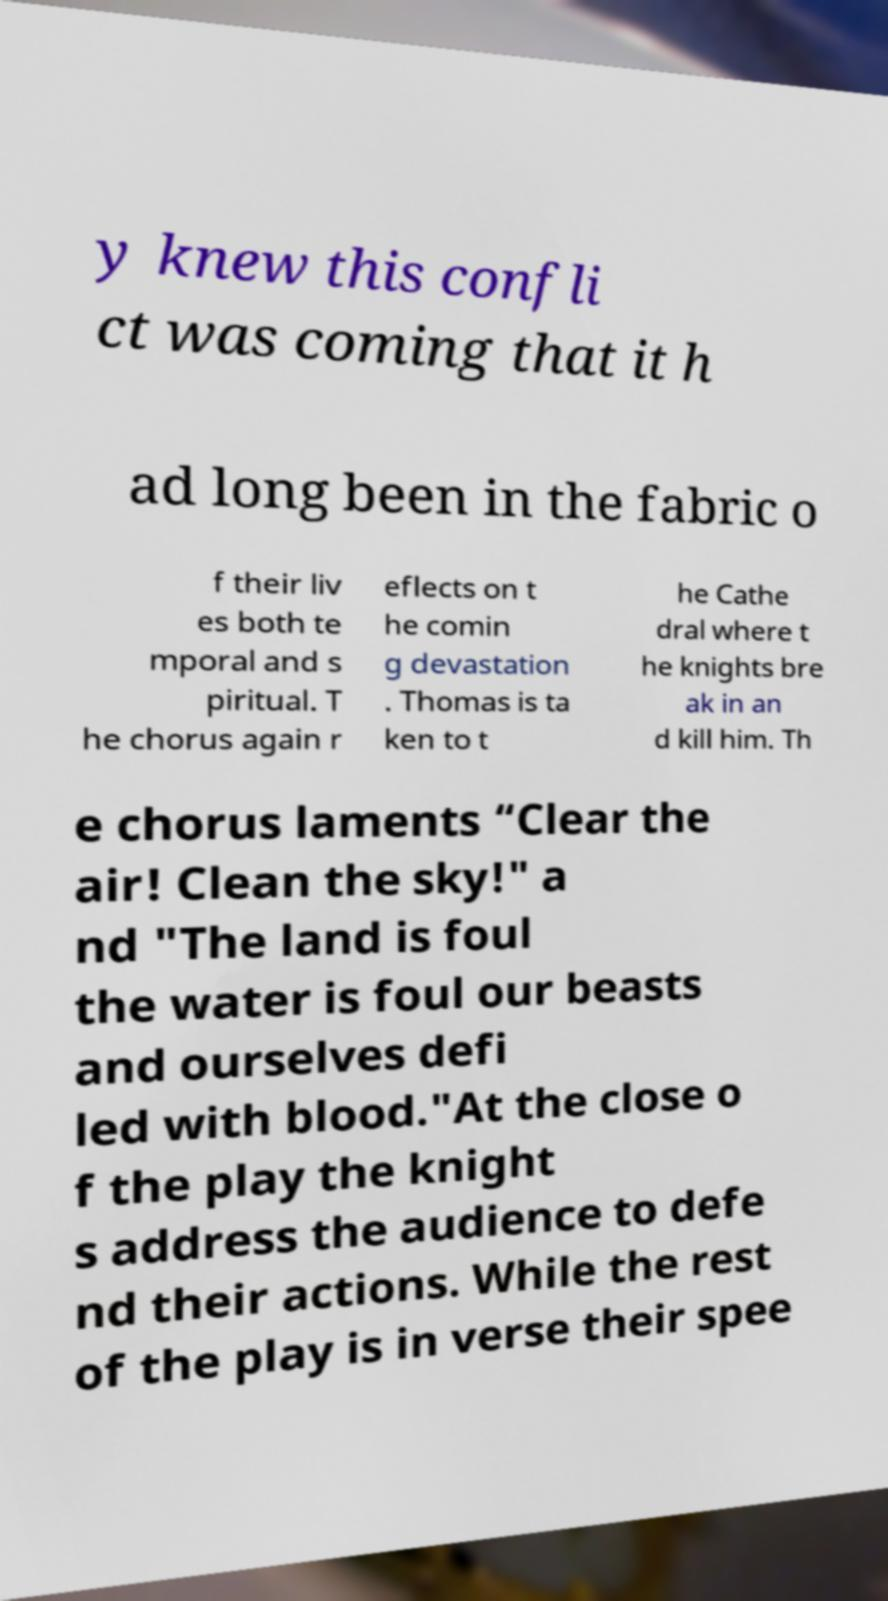For documentation purposes, I need the text within this image transcribed. Could you provide that? y knew this confli ct was coming that it h ad long been in the fabric o f their liv es both te mporal and s piritual. T he chorus again r eflects on t he comin g devastation . Thomas is ta ken to t he Cathe dral where t he knights bre ak in an d kill him. Th e chorus laments “Clear the air! Clean the sky!" a nd "The land is foul the water is foul our beasts and ourselves defi led with blood."At the close o f the play the knight s address the audience to defe nd their actions. While the rest of the play is in verse their spee 